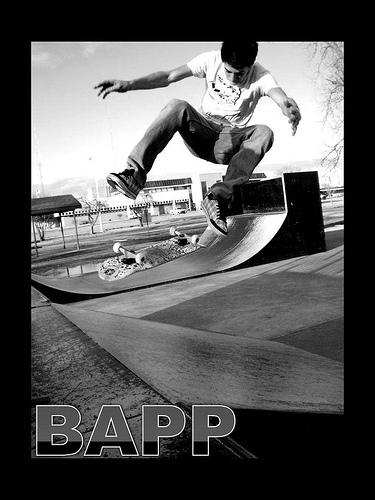World skate is the head controller of which sport? skateboarding 